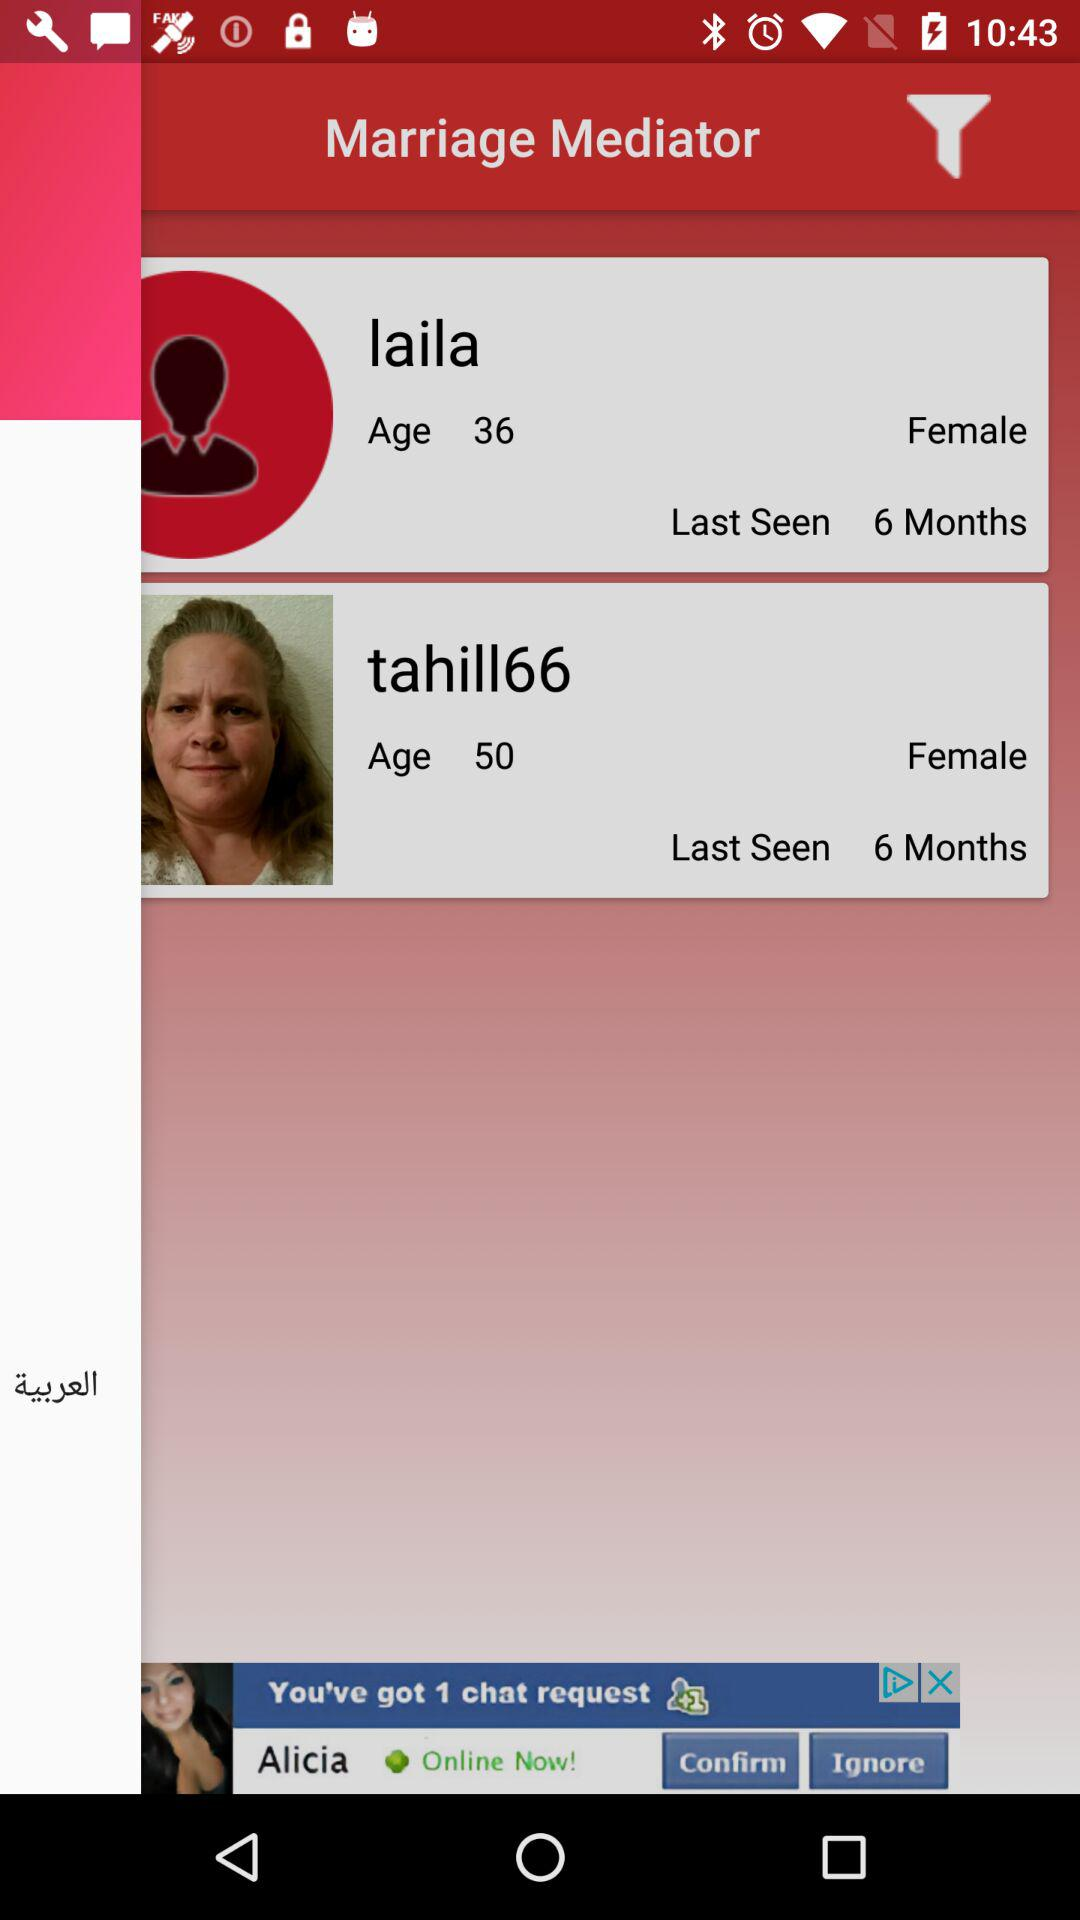What is the gender of tahill66? The gender is female. 